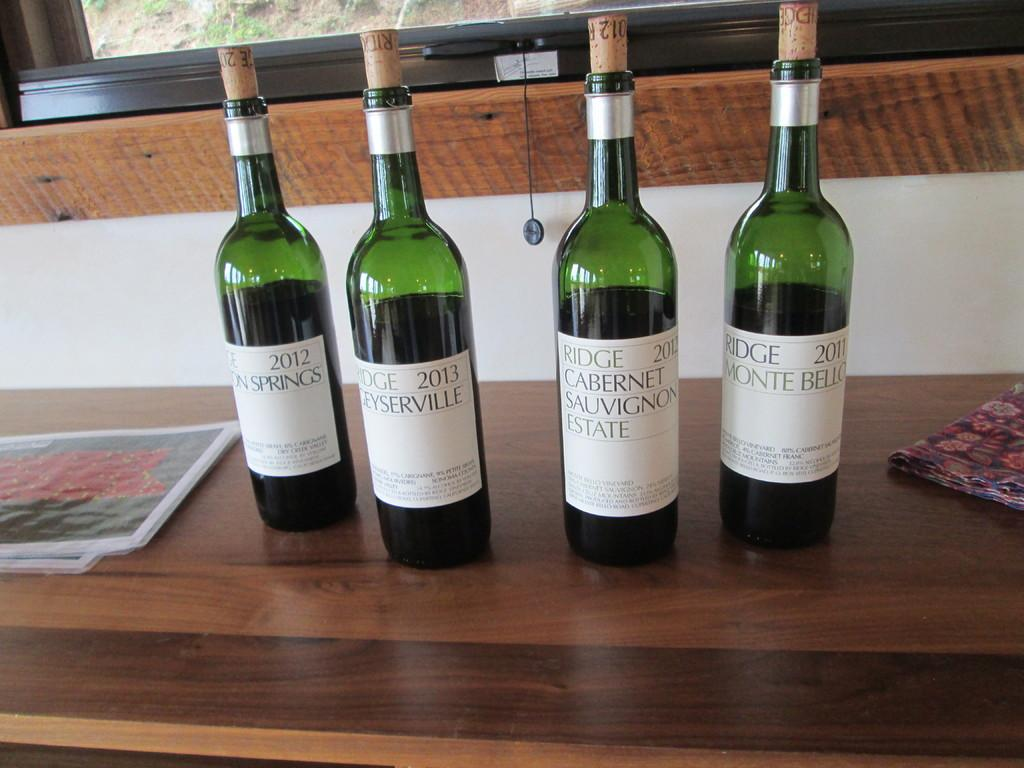<image>
Provide a brief description of the given image. THE WINE BOTTLES ARE FROM THE YEARS 2011, 2012 AND 2013 